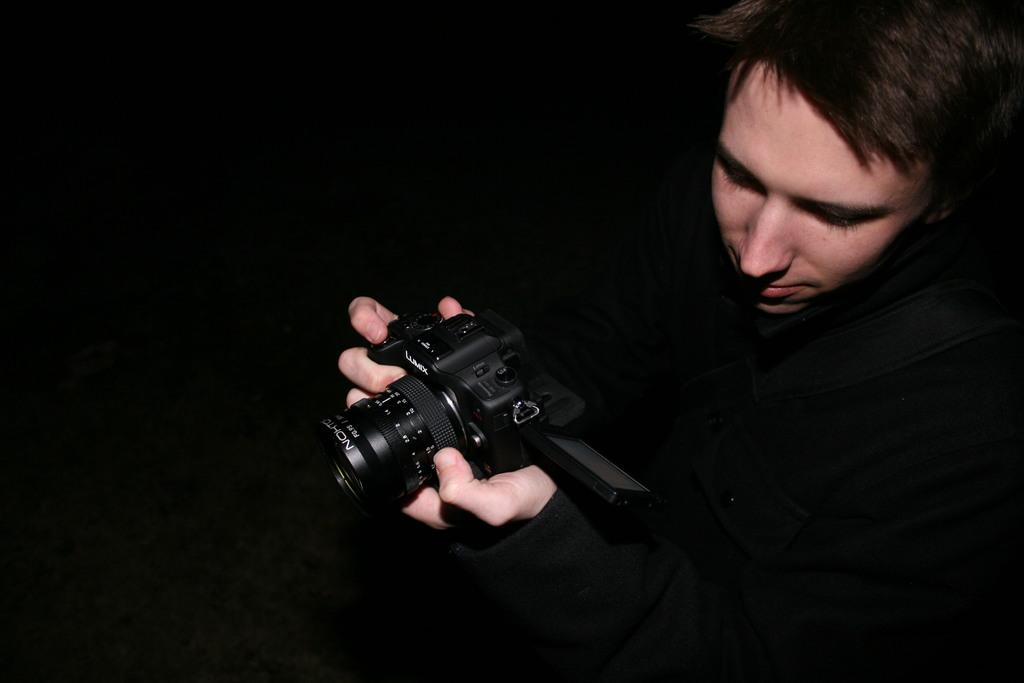What is the main subject of the image? There is a man in the image. What is the man holding in his hands? The man is holding a camera in his hands. What type of chalk is the man using to draw on the wall in the image? There is no chalk or wall present in the image; the man is holding a camera. 